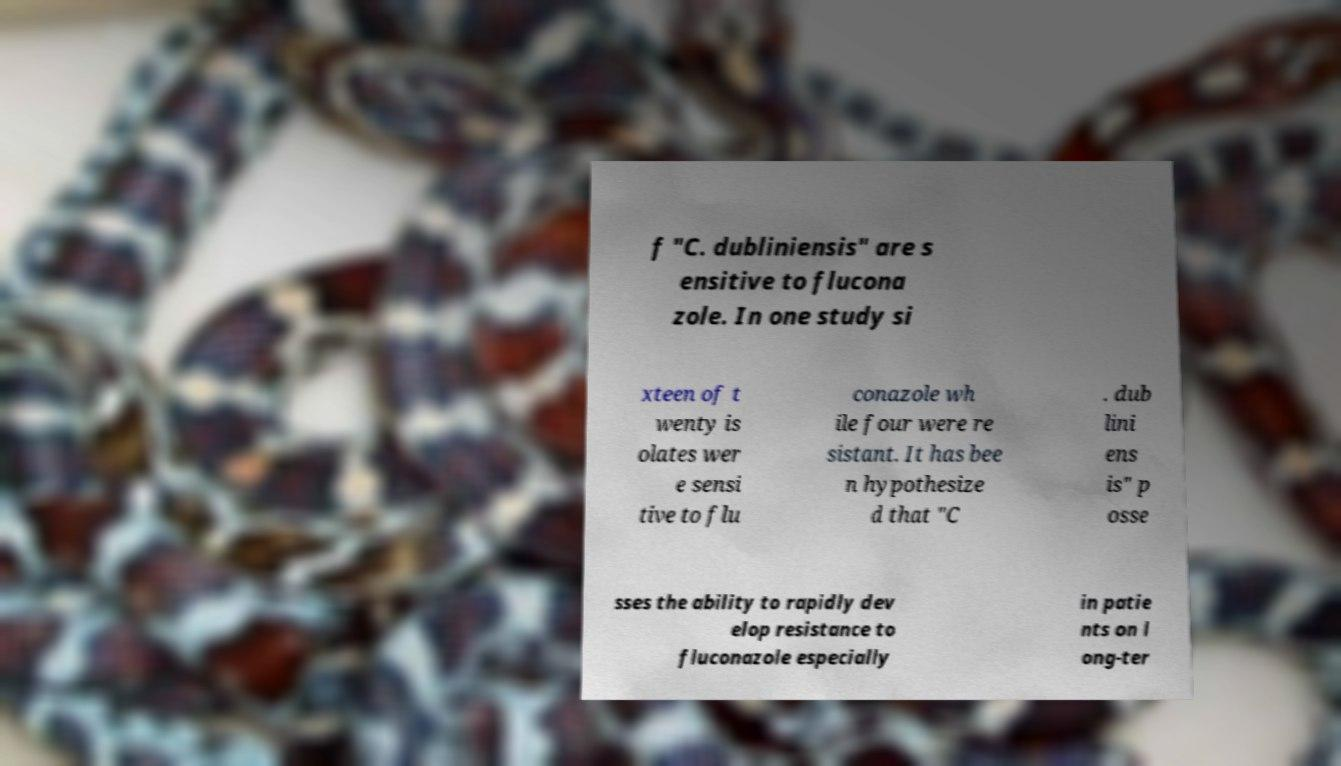There's text embedded in this image that I need extracted. Can you transcribe it verbatim? f "C. dubliniensis" are s ensitive to flucona zole. In one study si xteen of t wenty is olates wer e sensi tive to flu conazole wh ile four were re sistant. It has bee n hypothesize d that "C . dub lini ens is" p osse sses the ability to rapidly dev elop resistance to fluconazole especially in patie nts on l ong-ter 